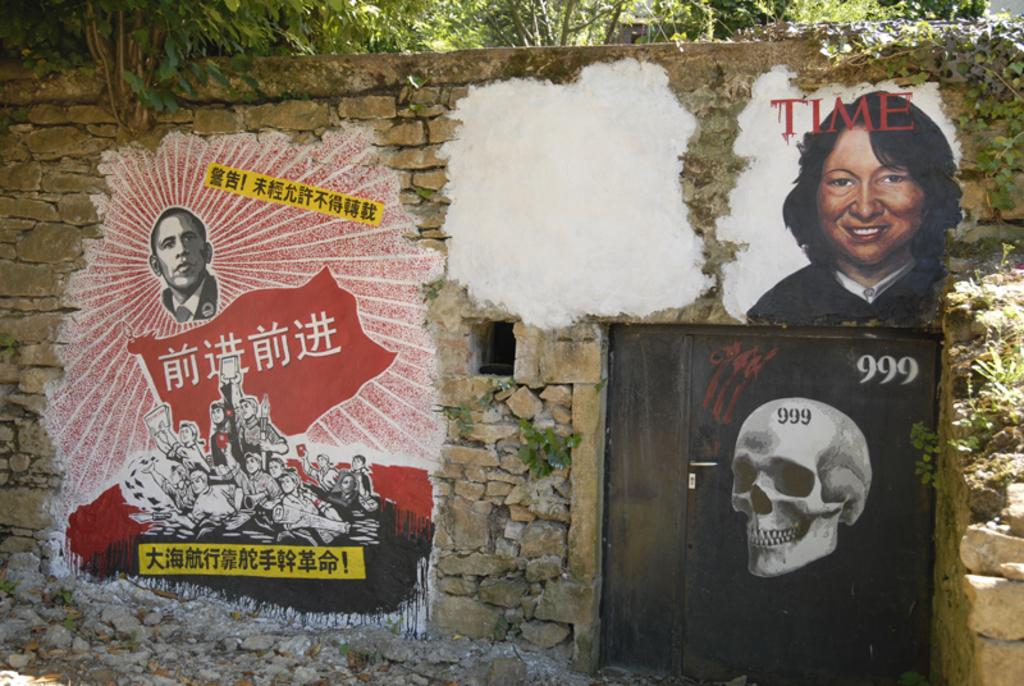What type of vegetation is visible at the top of the image? There are trees at the top side of the image. What can be seen on the wall in the image? There are posters on the wall in the image. How does the pest attempt to steal the wealth in the image? There is no pest or wealth present in the image, so this question cannot be answered. 